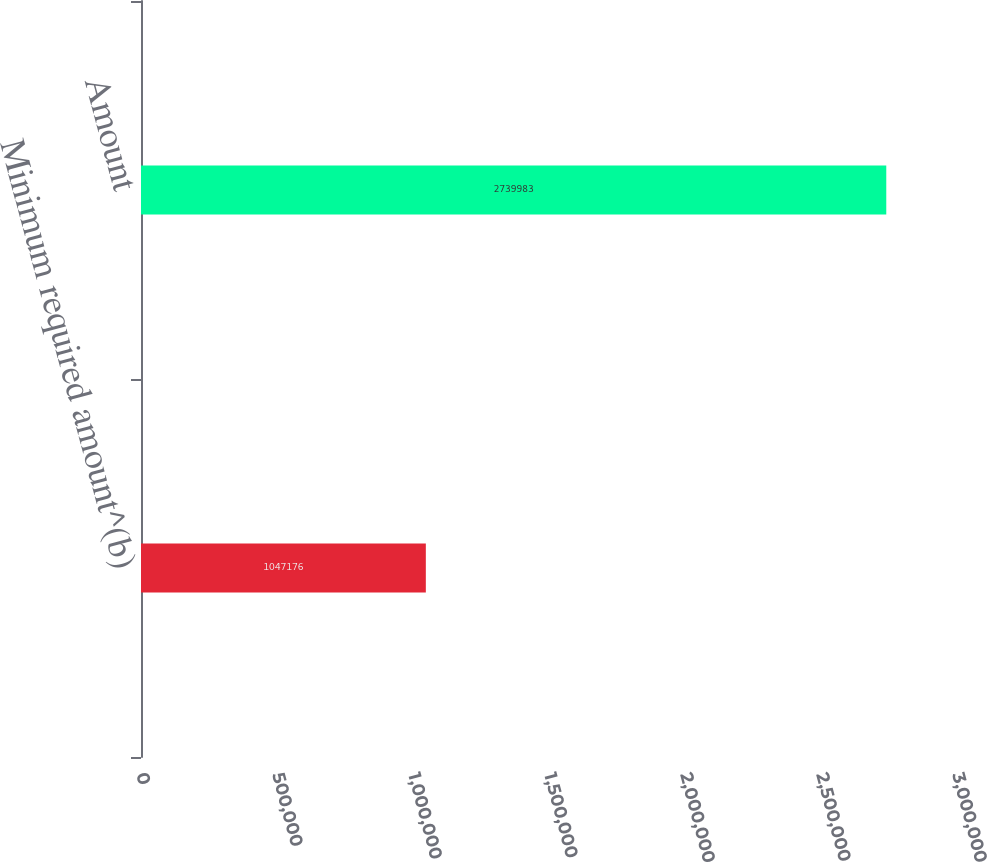Convert chart. <chart><loc_0><loc_0><loc_500><loc_500><bar_chart><fcel>Minimum required amount^(b)<fcel>Amount<nl><fcel>1.04718e+06<fcel>2.73998e+06<nl></chart> 